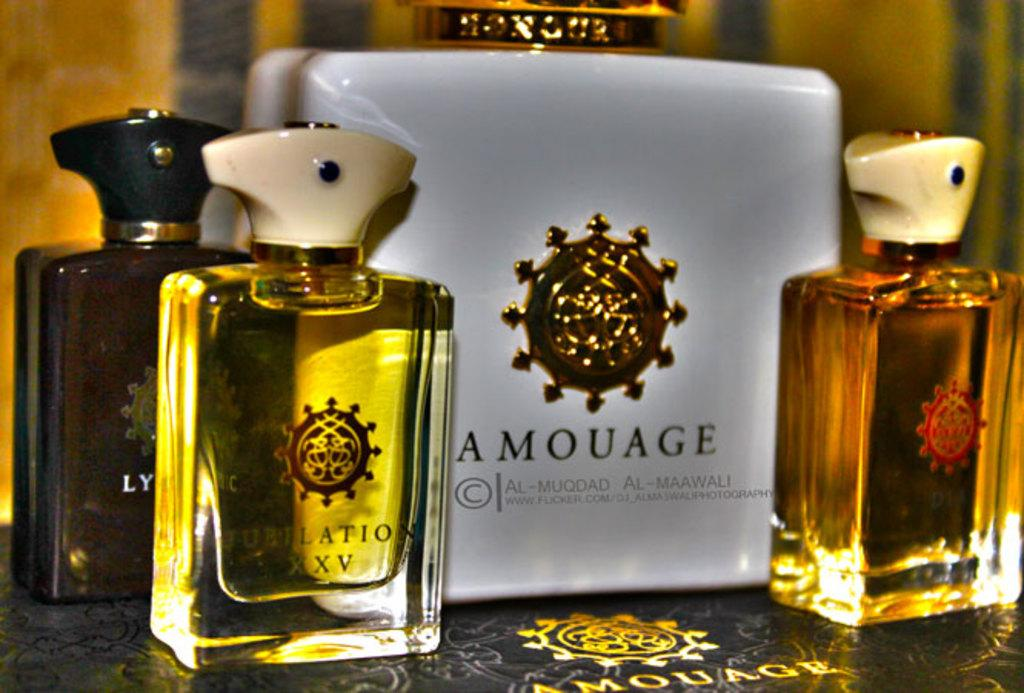<image>
Offer a succinct explanation of the picture presented. Three small bottles of perfume stand with a large bottle of Amouage. 